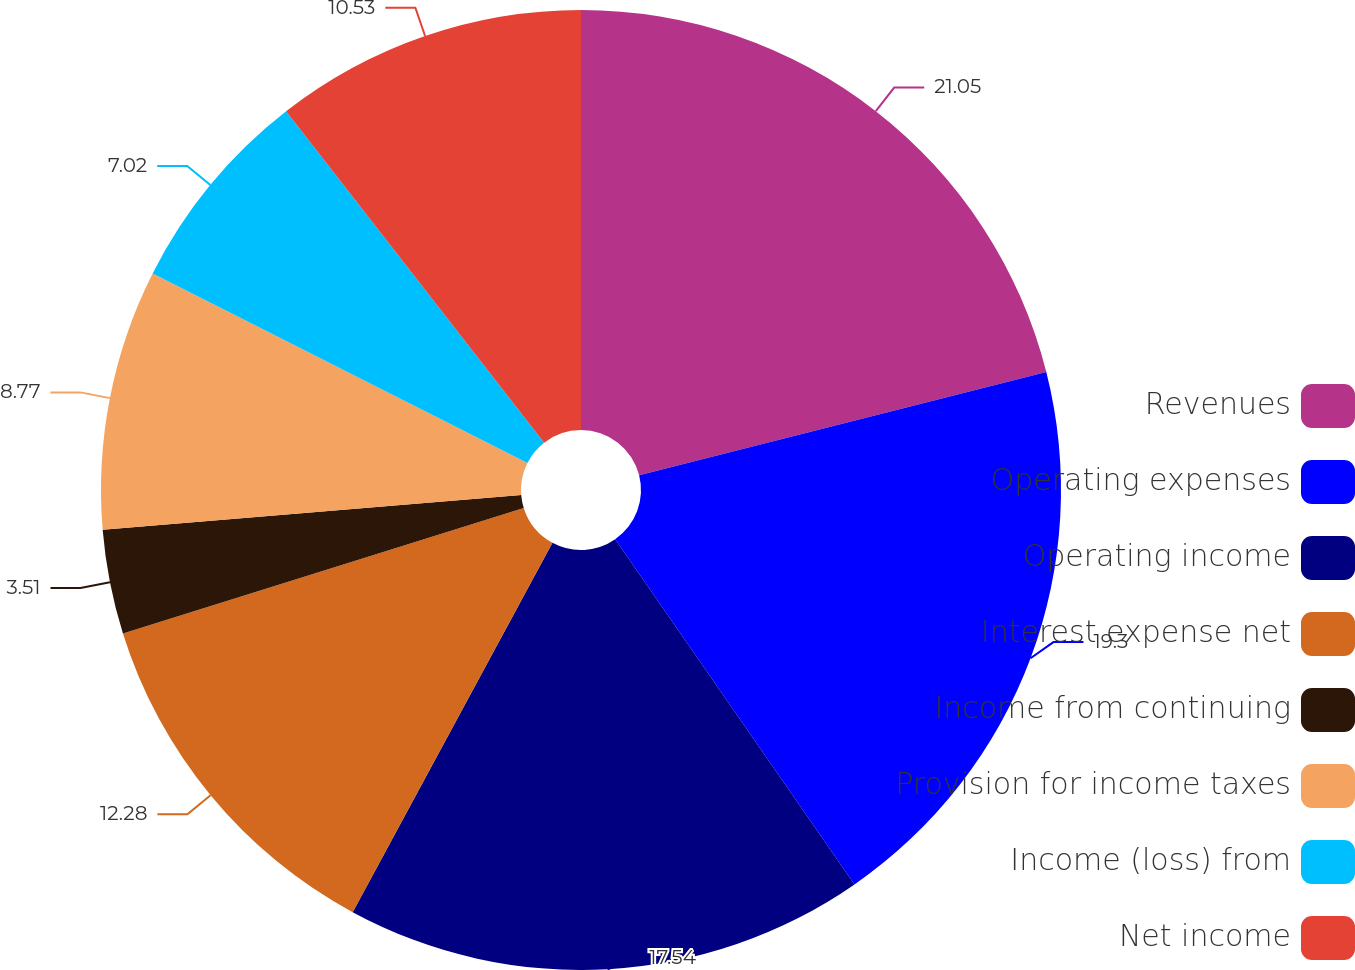Convert chart to OTSL. <chart><loc_0><loc_0><loc_500><loc_500><pie_chart><fcel>Revenues<fcel>Operating expenses<fcel>Operating income<fcel>Interest expense net<fcel>Income from continuing<fcel>Provision for income taxes<fcel>Income (loss) from<fcel>Net income<nl><fcel>21.05%<fcel>19.3%<fcel>17.54%<fcel>12.28%<fcel>3.51%<fcel>8.77%<fcel>7.02%<fcel>10.53%<nl></chart> 